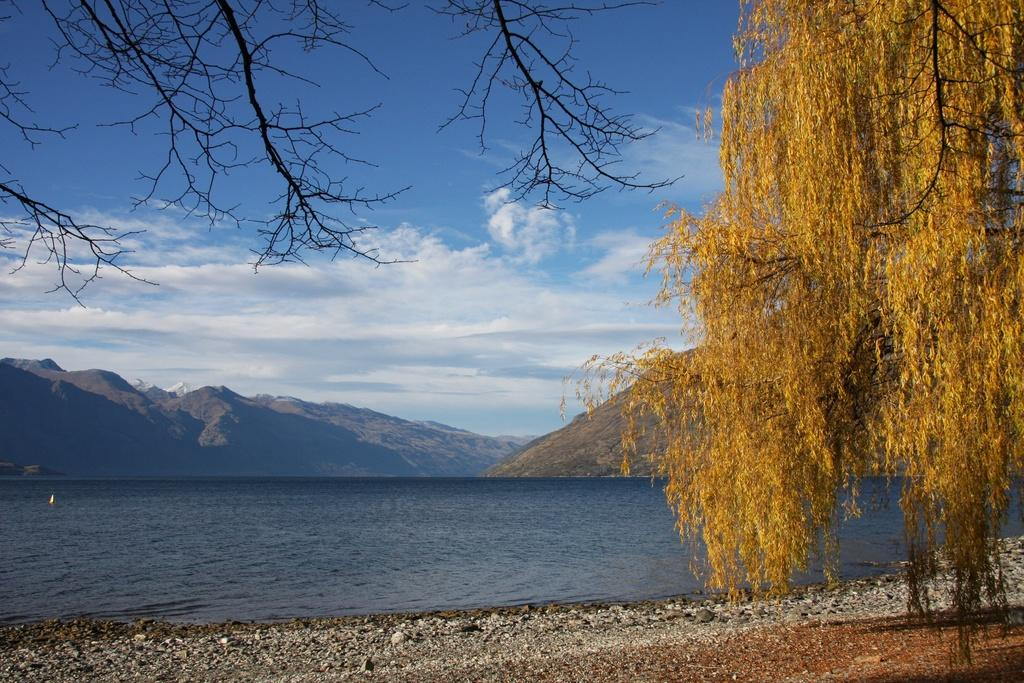What type of vegetation is present in the front of the image? There are trees in the front of the image. What can be seen in the background of the image? Water, mountains, clouds, and the sky are visible in the background of the image. Can you describe the natural features in the background of the image? The background features water, mountains, and clouds, with the sky visible above. How many balls are visible in the image? There are no balls present in the image. What type of crib is shown in the image? There is no crib present in the image. 